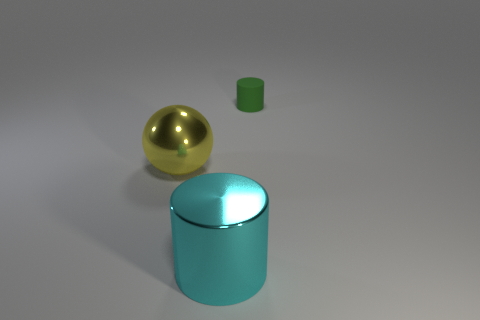Add 1 large shiny things. How many objects exist? 4 Subtract all cyan cylinders. Subtract all large spheres. How many objects are left? 1 Add 3 big cyan objects. How many big cyan objects are left? 4 Add 3 purple metallic things. How many purple metallic things exist? 3 Subtract 1 cyan cylinders. How many objects are left? 2 Subtract all cylinders. How many objects are left? 1 Subtract all gray spheres. Subtract all purple blocks. How many spheres are left? 1 Subtract all green cubes. How many green cylinders are left? 1 